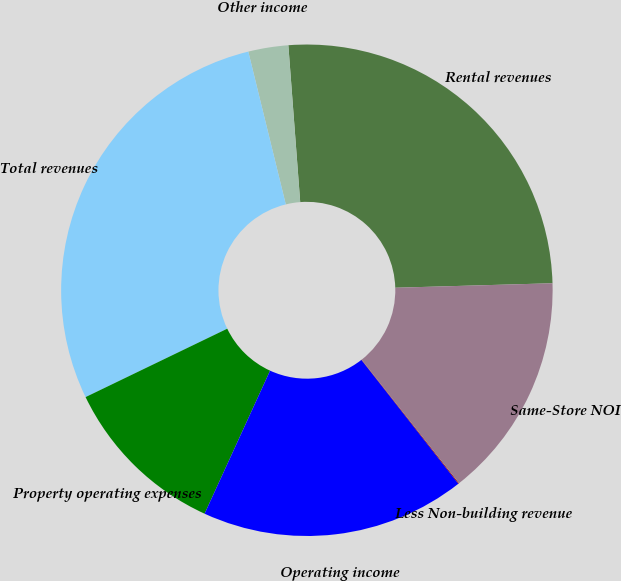Convert chart to OTSL. <chart><loc_0><loc_0><loc_500><loc_500><pie_chart><fcel>Rental revenues<fcel>Other income<fcel>Total revenues<fcel>Property operating expenses<fcel>Operating income<fcel>Less Non-building revenue<fcel>Same-Store NOI<nl><fcel>25.75%<fcel>2.63%<fcel>28.33%<fcel>11.01%<fcel>17.41%<fcel>0.05%<fcel>14.83%<nl></chart> 